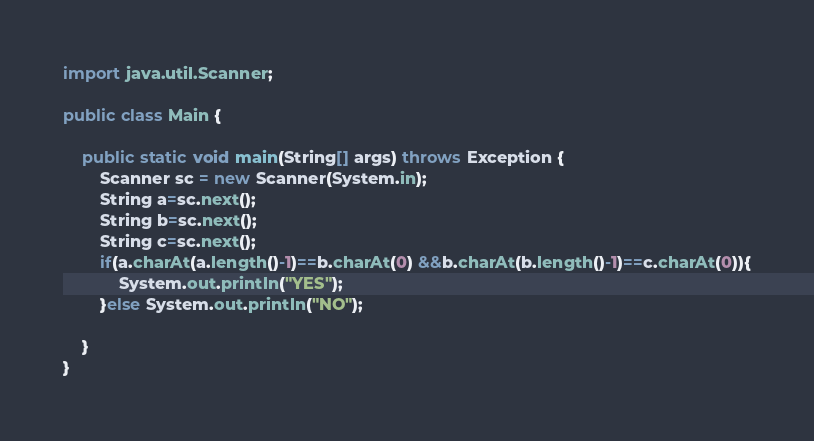Convert code to text. <code><loc_0><loc_0><loc_500><loc_500><_Java_>import java.util.Scanner;

public class Main {

	public static void main(String[] args) throws Exception {
		Scanner sc = new Scanner(System.in);
        String a=sc.next();
        String b=sc.next();
        String c=sc.next();
        if(a.charAt(a.length()-1)==b.charAt(0) &&b.charAt(b.length()-1)==c.charAt(0)){
            System.out.println("YES");
        }else System.out.println("NO");

	}
}
</code> 